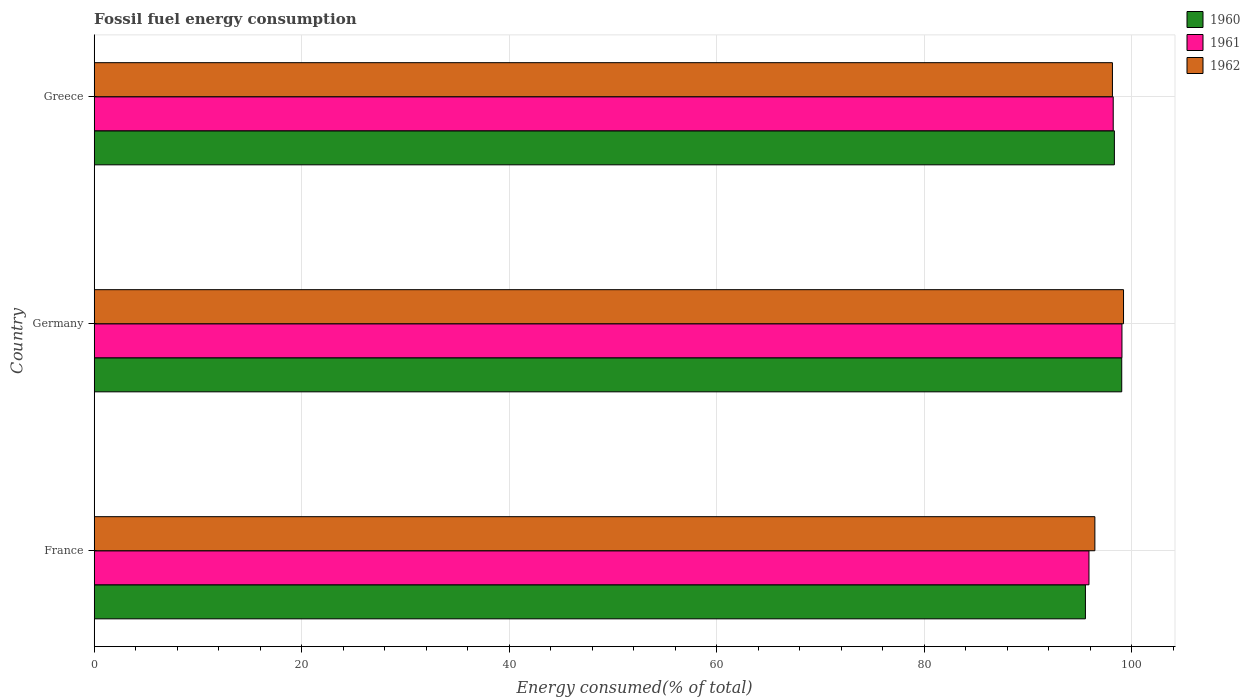How many different coloured bars are there?
Provide a short and direct response. 3. Are the number of bars on each tick of the Y-axis equal?
Make the answer very short. Yes. How many bars are there on the 3rd tick from the top?
Give a very brief answer. 3. In how many cases, is the number of bars for a given country not equal to the number of legend labels?
Provide a short and direct response. 0. What is the percentage of energy consumed in 1960 in Greece?
Provide a succinct answer. 98.31. Across all countries, what is the maximum percentage of energy consumed in 1960?
Provide a succinct answer. 99.02. Across all countries, what is the minimum percentage of energy consumed in 1960?
Provide a succinct answer. 95.52. In which country was the percentage of energy consumed in 1962 maximum?
Offer a very short reply. Germany. In which country was the percentage of energy consumed in 1962 minimum?
Provide a short and direct response. France. What is the total percentage of energy consumed in 1962 in the graph?
Provide a succinct answer. 293.75. What is the difference between the percentage of energy consumed in 1960 in France and that in Greece?
Ensure brevity in your answer.  -2.79. What is the difference between the percentage of energy consumed in 1961 in Greece and the percentage of energy consumed in 1960 in Germany?
Your answer should be compact. -0.82. What is the average percentage of energy consumed in 1961 per country?
Ensure brevity in your answer.  97.7. What is the difference between the percentage of energy consumed in 1961 and percentage of energy consumed in 1960 in France?
Offer a very short reply. 0.34. What is the ratio of the percentage of energy consumed in 1962 in France to that in Greece?
Your response must be concise. 0.98. What is the difference between the highest and the second highest percentage of energy consumed in 1960?
Keep it short and to the point. 0.71. What is the difference between the highest and the lowest percentage of energy consumed in 1962?
Your answer should be compact. 2.76. In how many countries, is the percentage of energy consumed in 1960 greater than the average percentage of energy consumed in 1960 taken over all countries?
Make the answer very short. 2. Are all the bars in the graph horizontal?
Provide a succinct answer. Yes. Are the values on the major ticks of X-axis written in scientific E-notation?
Keep it short and to the point. No. How are the legend labels stacked?
Offer a very short reply. Vertical. What is the title of the graph?
Ensure brevity in your answer.  Fossil fuel energy consumption. Does "1999" appear as one of the legend labels in the graph?
Keep it short and to the point. No. What is the label or title of the X-axis?
Ensure brevity in your answer.  Energy consumed(% of total). What is the label or title of the Y-axis?
Your answer should be compact. Country. What is the Energy consumed(% of total) in 1960 in France?
Your response must be concise. 95.52. What is the Energy consumed(% of total) in 1961 in France?
Your response must be concise. 95.86. What is the Energy consumed(% of total) of 1962 in France?
Ensure brevity in your answer.  96.43. What is the Energy consumed(% of total) in 1960 in Germany?
Keep it short and to the point. 99.02. What is the Energy consumed(% of total) of 1961 in Germany?
Your response must be concise. 99.04. What is the Energy consumed(% of total) in 1962 in Germany?
Ensure brevity in your answer.  99.19. What is the Energy consumed(% of total) of 1960 in Greece?
Provide a succinct answer. 98.31. What is the Energy consumed(% of total) of 1961 in Greece?
Offer a very short reply. 98.2. What is the Energy consumed(% of total) of 1962 in Greece?
Offer a terse response. 98.12. Across all countries, what is the maximum Energy consumed(% of total) of 1960?
Your response must be concise. 99.02. Across all countries, what is the maximum Energy consumed(% of total) of 1961?
Your answer should be compact. 99.04. Across all countries, what is the maximum Energy consumed(% of total) of 1962?
Ensure brevity in your answer.  99.19. Across all countries, what is the minimum Energy consumed(% of total) of 1960?
Your answer should be compact. 95.52. Across all countries, what is the minimum Energy consumed(% of total) of 1961?
Offer a terse response. 95.86. Across all countries, what is the minimum Energy consumed(% of total) of 1962?
Provide a succinct answer. 96.43. What is the total Energy consumed(% of total) of 1960 in the graph?
Provide a short and direct response. 292.85. What is the total Energy consumed(% of total) of 1961 in the graph?
Provide a succinct answer. 293.1. What is the total Energy consumed(% of total) in 1962 in the graph?
Give a very brief answer. 293.75. What is the difference between the Energy consumed(% of total) in 1961 in France and that in Germany?
Your response must be concise. -3.18. What is the difference between the Energy consumed(% of total) in 1962 in France and that in Germany?
Ensure brevity in your answer.  -2.76. What is the difference between the Energy consumed(% of total) of 1960 in France and that in Greece?
Ensure brevity in your answer.  -2.79. What is the difference between the Energy consumed(% of total) in 1961 in France and that in Greece?
Provide a succinct answer. -2.34. What is the difference between the Energy consumed(% of total) of 1962 in France and that in Greece?
Provide a succinct answer. -1.69. What is the difference between the Energy consumed(% of total) in 1960 in Germany and that in Greece?
Ensure brevity in your answer.  0.71. What is the difference between the Energy consumed(% of total) in 1961 in Germany and that in Greece?
Give a very brief answer. 0.84. What is the difference between the Energy consumed(% of total) in 1962 in Germany and that in Greece?
Your answer should be compact. 1.07. What is the difference between the Energy consumed(% of total) in 1960 in France and the Energy consumed(% of total) in 1961 in Germany?
Your response must be concise. -3.52. What is the difference between the Energy consumed(% of total) in 1960 in France and the Energy consumed(% of total) in 1962 in Germany?
Your answer should be compact. -3.67. What is the difference between the Energy consumed(% of total) in 1961 in France and the Energy consumed(% of total) in 1962 in Germany?
Ensure brevity in your answer.  -3.33. What is the difference between the Energy consumed(% of total) in 1960 in France and the Energy consumed(% of total) in 1961 in Greece?
Ensure brevity in your answer.  -2.68. What is the difference between the Energy consumed(% of total) in 1960 in France and the Energy consumed(% of total) in 1962 in Greece?
Offer a terse response. -2.6. What is the difference between the Energy consumed(% of total) in 1961 in France and the Energy consumed(% of total) in 1962 in Greece?
Provide a short and direct response. -2.26. What is the difference between the Energy consumed(% of total) in 1960 in Germany and the Energy consumed(% of total) in 1961 in Greece?
Your response must be concise. 0.82. What is the difference between the Energy consumed(% of total) in 1960 in Germany and the Energy consumed(% of total) in 1962 in Greece?
Offer a terse response. 0.9. What is the difference between the Energy consumed(% of total) in 1961 in Germany and the Energy consumed(% of total) in 1962 in Greece?
Make the answer very short. 0.92. What is the average Energy consumed(% of total) of 1960 per country?
Offer a terse response. 97.62. What is the average Energy consumed(% of total) in 1961 per country?
Ensure brevity in your answer.  97.7. What is the average Energy consumed(% of total) in 1962 per country?
Your response must be concise. 97.92. What is the difference between the Energy consumed(% of total) in 1960 and Energy consumed(% of total) in 1961 in France?
Provide a short and direct response. -0.34. What is the difference between the Energy consumed(% of total) of 1960 and Energy consumed(% of total) of 1962 in France?
Your answer should be compact. -0.91. What is the difference between the Energy consumed(% of total) in 1961 and Energy consumed(% of total) in 1962 in France?
Provide a succinct answer. -0.57. What is the difference between the Energy consumed(% of total) in 1960 and Energy consumed(% of total) in 1961 in Germany?
Offer a very short reply. -0.02. What is the difference between the Energy consumed(% of total) in 1960 and Energy consumed(% of total) in 1962 in Germany?
Give a very brief answer. -0.17. What is the difference between the Energy consumed(% of total) of 1961 and Energy consumed(% of total) of 1962 in Germany?
Give a very brief answer. -0.15. What is the difference between the Energy consumed(% of total) of 1960 and Energy consumed(% of total) of 1961 in Greece?
Provide a succinct answer. 0.11. What is the difference between the Energy consumed(% of total) of 1960 and Energy consumed(% of total) of 1962 in Greece?
Make the answer very short. 0.19. What is the difference between the Energy consumed(% of total) of 1961 and Energy consumed(% of total) of 1962 in Greece?
Give a very brief answer. 0.07. What is the ratio of the Energy consumed(% of total) of 1960 in France to that in Germany?
Offer a terse response. 0.96. What is the ratio of the Energy consumed(% of total) in 1961 in France to that in Germany?
Offer a terse response. 0.97. What is the ratio of the Energy consumed(% of total) of 1962 in France to that in Germany?
Ensure brevity in your answer.  0.97. What is the ratio of the Energy consumed(% of total) in 1960 in France to that in Greece?
Your response must be concise. 0.97. What is the ratio of the Energy consumed(% of total) in 1961 in France to that in Greece?
Provide a succinct answer. 0.98. What is the ratio of the Energy consumed(% of total) in 1962 in France to that in Greece?
Keep it short and to the point. 0.98. What is the ratio of the Energy consumed(% of total) in 1960 in Germany to that in Greece?
Your answer should be compact. 1.01. What is the ratio of the Energy consumed(% of total) of 1961 in Germany to that in Greece?
Your answer should be compact. 1.01. What is the ratio of the Energy consumed(% of total) of 1962 in Germany to that in Greece?
Make the answer very short. 1.01. What is the difference between the highest and the second highest Energy consumed(% of total) in 1960?
Your answer should be very brief. 0.71. What is the difference between the highest and the second highest Energy consumed(% of total) in 1961?
Keep it short and to the point. 0.84. What is the difference between the highest and the second highest Energy consumed(% of total) in 1962?
Make the answer very short. 1.07. What is the difference between the highest and the lowest Energy consumed(% of total) of 1960?
Your answer should be compact. 3.5. What is the difference between the highest and the lowest Energy consumed(% of total) of 1961?
Provide a short and direct response. 3.18. What is the difference between the highest and the lowest Energy consumed(% of total) in 1962?
Keep it short and to the point. 2.76. 